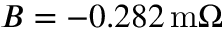Convert formula to latex. <formula><loc_0><loc_0><loc_500><loc_500>B = - 0 . 2 8 2 \, m \Omega</formula> 